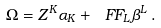<formula> <loc_0><loc_0><loc_500><loc_500>\Omega = Z ^ { K } \alpha _ { K } + \ F F _ { L } \beta ^ { L } \, .</formula> 